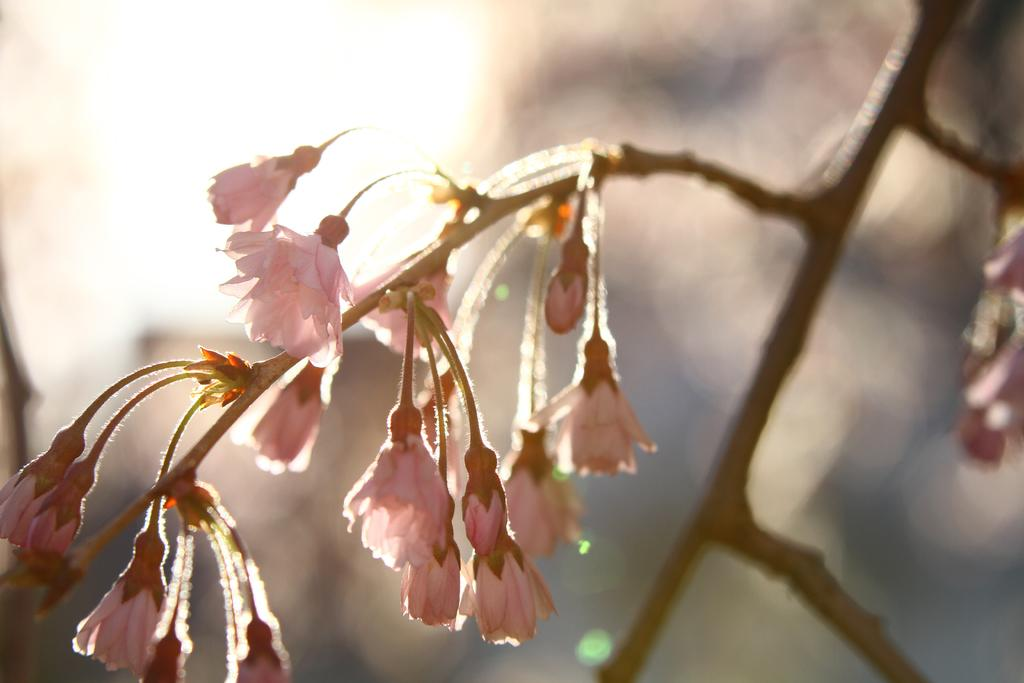What type of plant life is visible in the image? There are flowers in the image. Where are the flowers located on the tree? The flowers are on a branch of a tree. How many fingers can be seen stretching towards the flowers in the image? There are no fingers or stretching actions visible in the image; it only features flowers on a tree branch. 